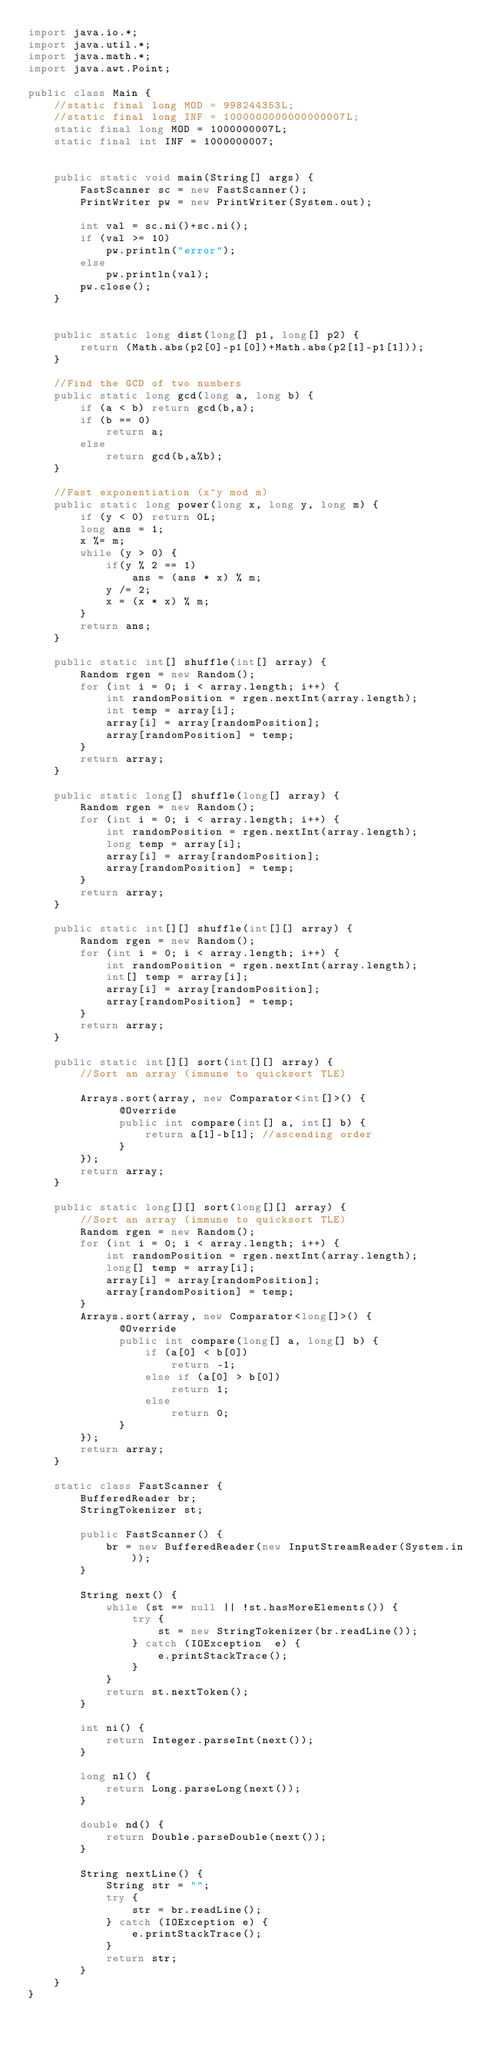Convert code to text. <code><loc_0><loc_0><loc_500><loc_500><_Java_>import java.io.*;
import java.util.*;
import java.math.*;
import java.awt.Point;
 
public class Main {
	//static final long MOD = 998244353L;
	//static final long INF = 1000000000000000007L;
	static final long MOD = 1000000007L;
	static final int INF = 1000000007;
	
	
	public static void main(String[] args) {
		FastScanner sc = new FastScanner();
		PrintWriter pw = new PrintWriter(System.out);
		
		int val = sc.ni()+sc.ni();
		if (val >= 10)
			pw.println("error");
		else
			pw.println(val);
		pw.close();
	}
 
 
	public static long dist(long[] p1, long[] p2) {
		return (Math.abs(p2[0]-p1[0])+Math.abs(p2[1]-p1[1]));
	}
	
	//Find the GCD of two numbers
	public static long gcd(long a, long b) {
		if (a < b) return gcd(b,a);
		if (b == 0)
			return a;
		else
			return gcd(b,a%b);
	}
	
	//Fast exponentiation (x^y mod m)
	public static long power(long x, long y, long m) { 
		if (y < 0) return 0L;
		long ans = 1;
		x %= m;
		while (y > 0) { 
			if(y % 2 == 1) 
				ans = (ans * x) % m; 
			y /= 2;  
			x = (x * x) % m;
		} 
		return ans; 
	}
	
	public static int[] shuffle(int[] array) {
		Random rgen = new Random();
		for (int i = 0; i < array.length; i++) {
		    int randomPosition = rgen.nextInt(array.length);
		    int temp = array[i];
		    array[i] = array[randomPosition];
		    array[randomPosition] = temp;
		}
		return array;
	}
	
	public static long[] shuffle(long[] array) {
		Random rgen = new Random();
		for (int i = 0; i < array.length; i++) {
		    int randomPosition = rgen.nextInt(array.length);
		    long temp = array[i];
		    array[i] = array[randomPosition];
		    array[randomPosition] = temp;
		}
		return array;
	}
	
	public static int[][] shuffle(int[][] array) {
		Random rgen = new Random();
		for (int i = 0; i < array.length; i++) {
		    int randomPosition = rgen.nextInt(array.length);
		    int[] temp = array[i];
		    array[i] = array[randomPosition];
		    array[randomPosition] = temp;
		}
		return array;
	}
	
    public static int[][] sort(int[][] array) {
    	//Sort an array (immune to quicksort TLE)
 
		Arrays.sort(array, new Comparator<int[]>() {
			  @Override
        	  public int compare(int[] a, int[] b) {
				  return a[1]-b[1]; //ascending order
	          }
		});
		return array;
	}
    
    public static long[][] sort(long[][] array) {
    	//Sort an array (immune to quicksort TLE)
		Random rgen = new Random();
		for (int i = 0; i < array.length; i++) {
		    int randomPosition = rgen.nextInt(array.length);
		    long[] temp = array[i];
		    array[i] = array[randomPosition];
		    array[randomPosition] = temp;
		}
		Arrays.sort(array, new Comparator<long[]>() {
			  @Override
        	  public int compare(long[] a, long[] b) {
				  if (a[0] < b[0])
					  return -1;
				  else if (a[0] > b[0])
					  return 1;
				  else
					  return 0;
	          }
		});
		return array;
	}
    
    static class FastScanner { 
        BufferedReader br; 
        StringTokenizer st; 
  
        public FastScanner() { 
            br = new BufferedReader(new InputStreamReader(System.in)); 
        } 
  
        String next() { 
            while (st == null || !st.hasMoreElements()) { 
                try { 
                    st = new StringTokenizer(br.readLine());
                } catch (IOException  e) { 
                    e.printStackTrace(); 
                } 
            } 
            return st.nextToken(); 
        }
        
        int ni() { 
            return Integer.parseInt(next()); 
        }
  
        long nl() { 
            return Long.parseLong(next()); 
        } 
  
        double nd() { 
            return Double.parseDouble(next()); 
        } 
  
        String nextLine() {
            String str = ""; 
            try { 
                str = br.readLine(); 
            } catch (IOException e) {
                e.printStackTrace(); 
            } 
            return str;
        }
    }
}</code> 